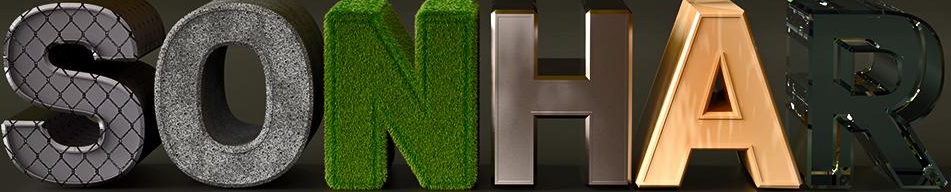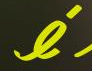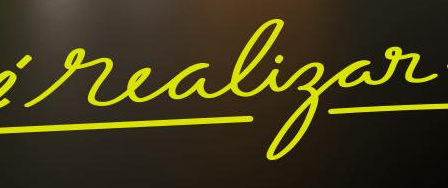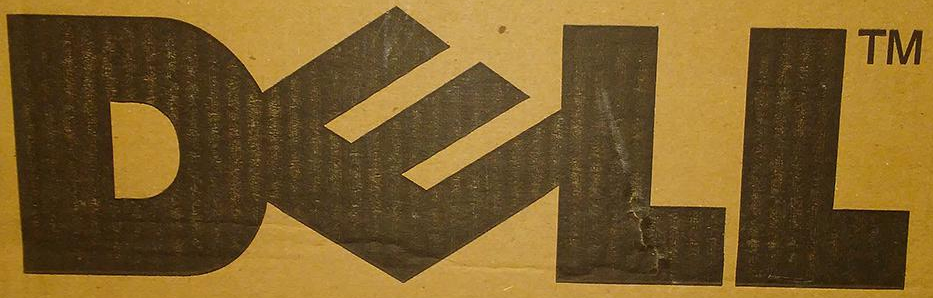Identify the words shown in these images in order, separated by a semicolon. SONHAR; é; realigar; DELL 